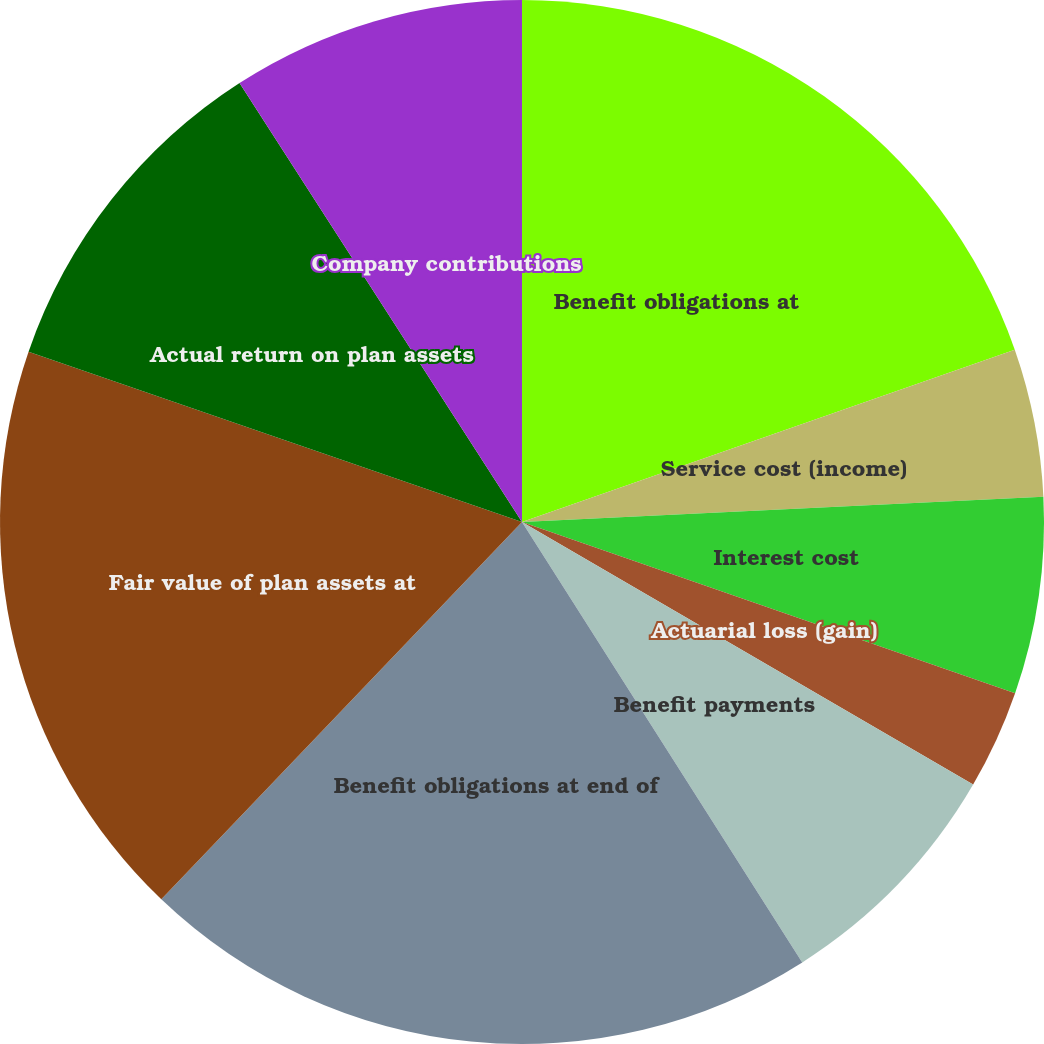Convert chart. <chart><loc_0><loc_0><loc_500><loc_500><pie_chart><fcel>Benefit obligations at<fcel>Service cost (income)<fcel>Interest cost<fcel>Actuarial loss (gain)<fcel>Benefit payments<fcel>Benefit obligations at end of<fcel>Fair value of plan assets at<fcel>Actual return on plan assets<fcel>Company contributions<nl><fcel>19.65%<fcel>4.58%<fcel>6.09%<fcel>3.07%<fcel>7.59%<fcel>21.16%<fcel>18.15%<fcel>10.61%<fcel>9.1%<nl></chart> 